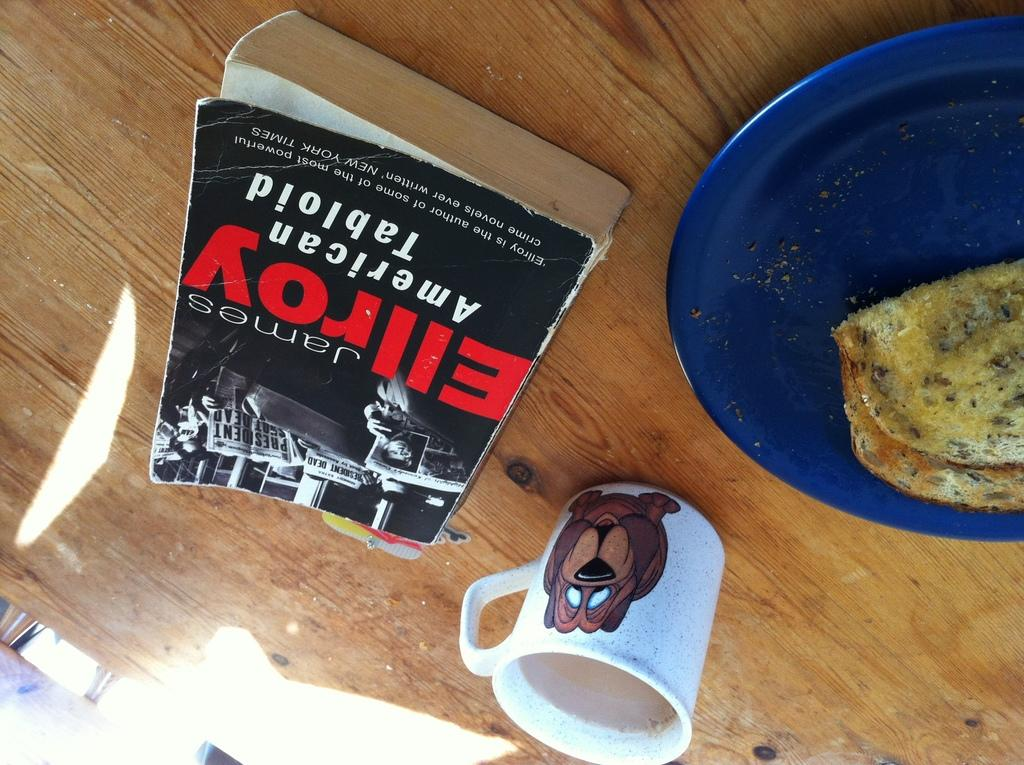<image>
Share a concise interpretation of the image provided. A book titled Ellroy is on a table near a plate of food. 